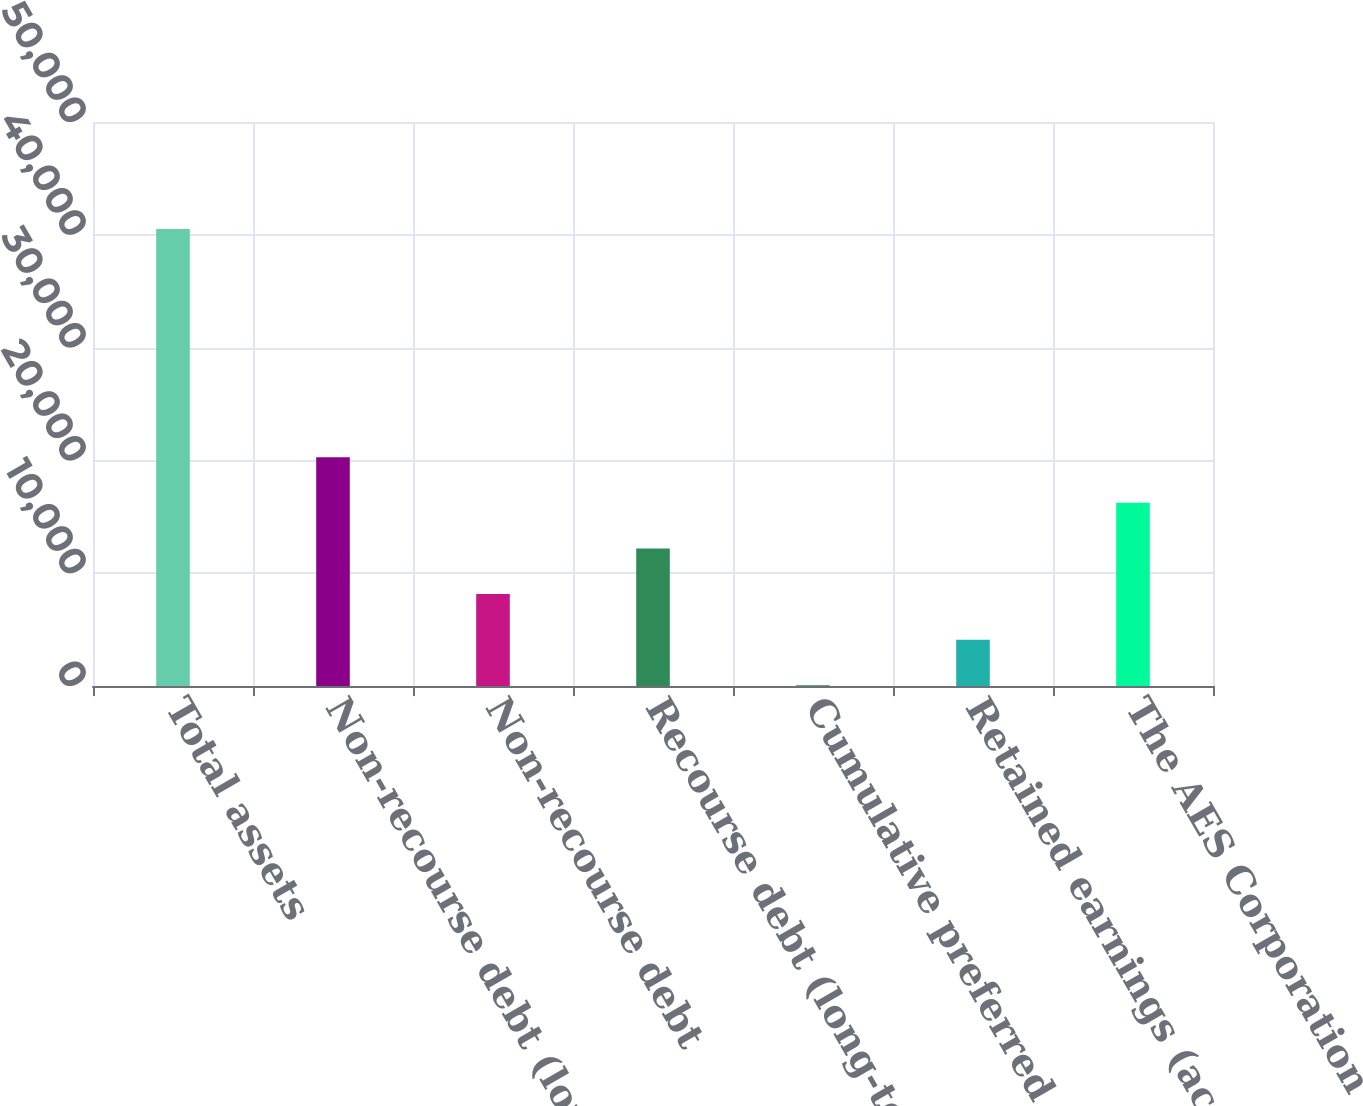Convert chart to OTSL. <chart><loc_0><loc_0><loc_500><loc_500><bar_chart><fcel>Total assets<fcel>Non-recourse debt (long-term)<fcel>Non-recourse debt<fcel>Recourse debt (long-term)<fcel>Cumulative preferred stock of<fcel>Retained earnings (accumulated<fcel>The AES Corporation<nl><fcel>40511<fcel>20285.5<fcel>8150.2<fcel>12195.3<fcel>60<fcel>4105.1<fcel>16240.4<nl></chart> 